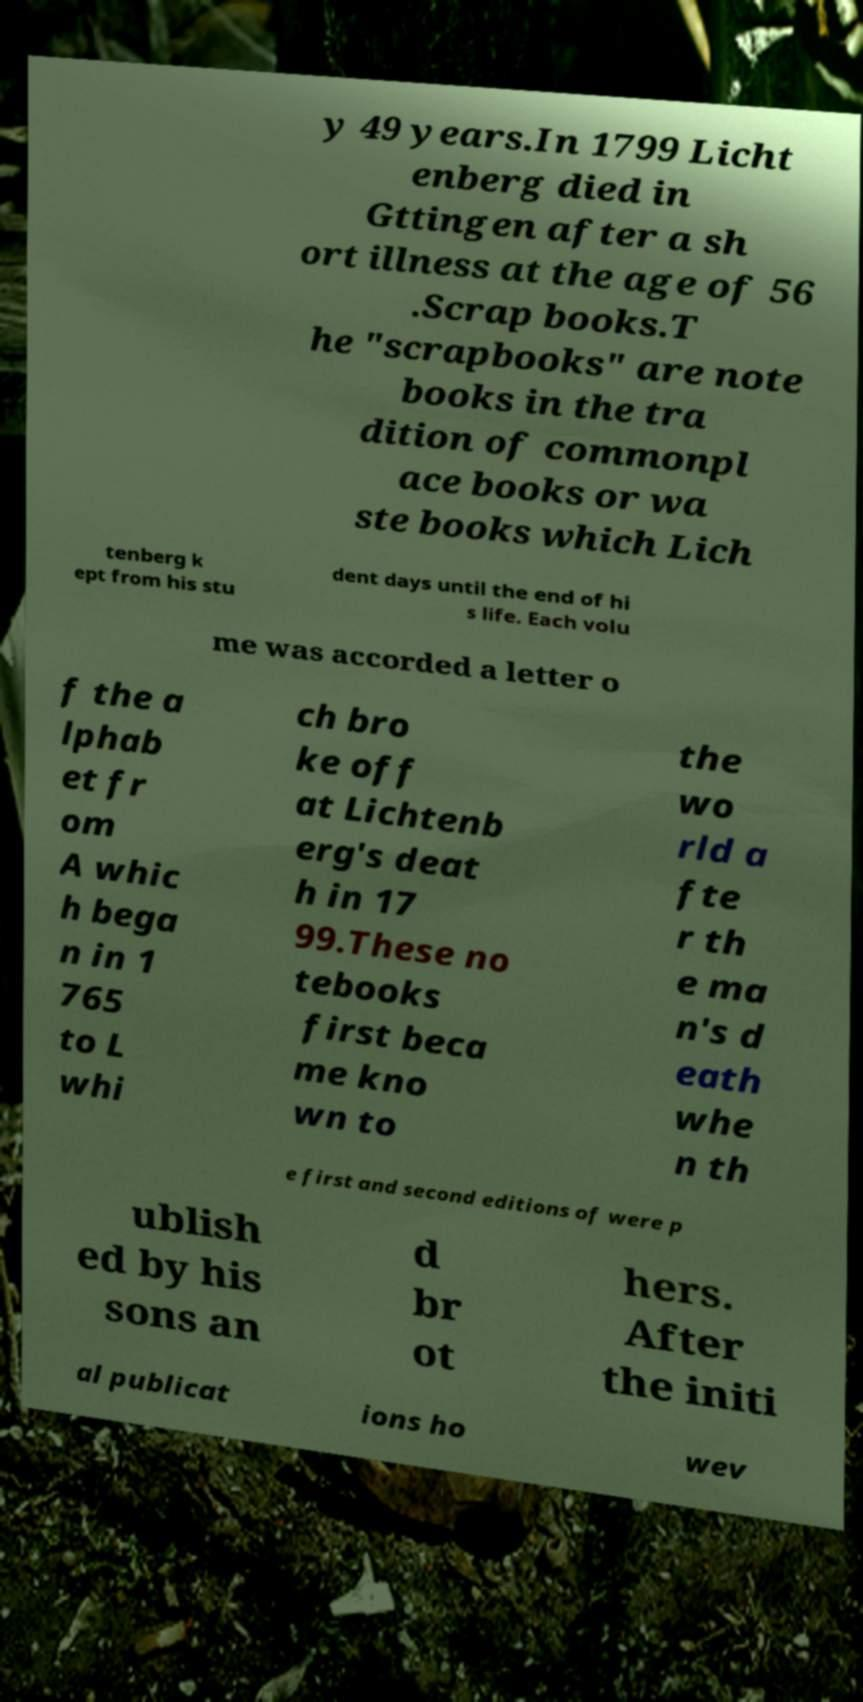Could you assist in decoding the text presented in this image and type it out clearly? y 49 years.In 1799 Licht enberg died in Gttingen after a sh ort illness at the age of 56 .Scrap books.T he "scrapbooks" are note books in the tra dition of commonpl ace books or wa ste books which Lich tenberg k ept from his stu dent days until the end of hi s life. Each volu me was accorded a letter o f the a lphab et fr om A whic h bega n in 1 765 to L whi ch bro ke off at Lichtenb erg's deat h in 17 99.These no tebooks first beca me kno wn to the wo rld a fte r th e ma n's d eath whe n th e first and second editions of were p ublish ed by his sons an d br ot hers. After the initi al publicat ions ho wev 